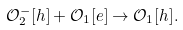<formula> <loc_0><loc_0><loc_500><loc_500>\mathcal { O } _ { 2 } ^ { - } [ h ] + \mathcal { O } _ { 1 } [ e ] \rightarrow \mathcal { O } _ { 1 } [ h ] .</formula> 